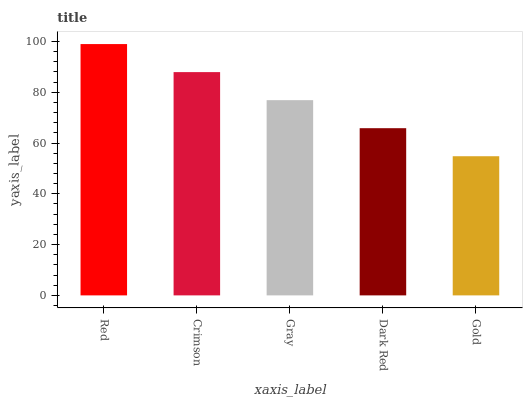Is Gold the minimum?
Answer yes or no. Yes. Is Red the maximum?
Answer yes or no. Yes. Is Crimson the minimum?
Answer yes or no. No. Is Crimson the maximum?
Answer yes or no. No. Is Red greater than Crimson?
Answer yes or no. Yes. Is Crimson less than Red?
Answer yes or no. Yes. Is Crimson greater than Red?
Answer yes or no. No. Is Red less than Crimson?
Answer yes or no. No. Is Gray the high median?
Answer yes or no. Yes. Is Gray the low median?
Answer yes or no. Yes. Is Crimson the high median?
Answer yes or no. No. Is Gold the low median?
Answer yes or no. No. 